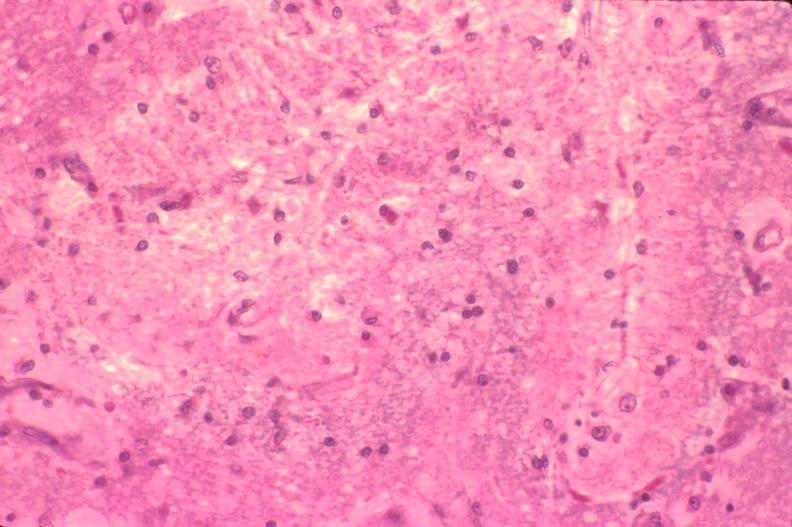what is present?
Answer the question using a single word or phrase. Nervous 